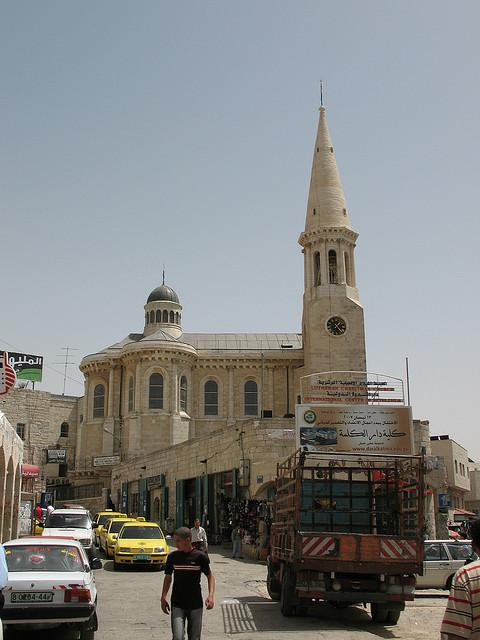What sound source can be found above the clock here? bell 